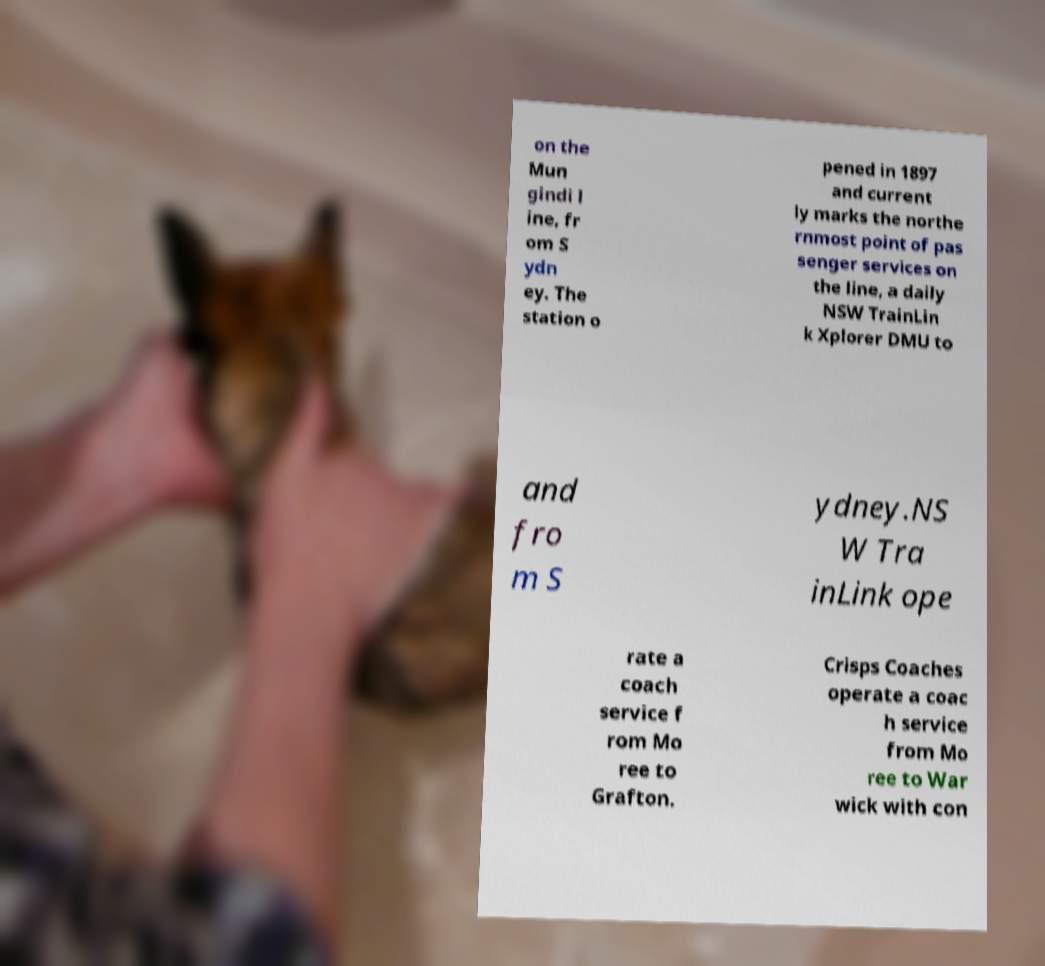There's text embedded in this image that I need extracted. Can you transcribe it verbatim? on the Mun gindi l ine, fr om S ydn ey. The station o pened in 1897 and current ly marks the northe rnmost point of pas senger services on the line, a daily NSW TrainLin k Xplorer DMU to and fro m S ydney.NS W Tra inLink ope rate a coach service f rom Mo ree to Grafton. Crisps Coaches operate a coac h service from Mo ree to War wick with con 